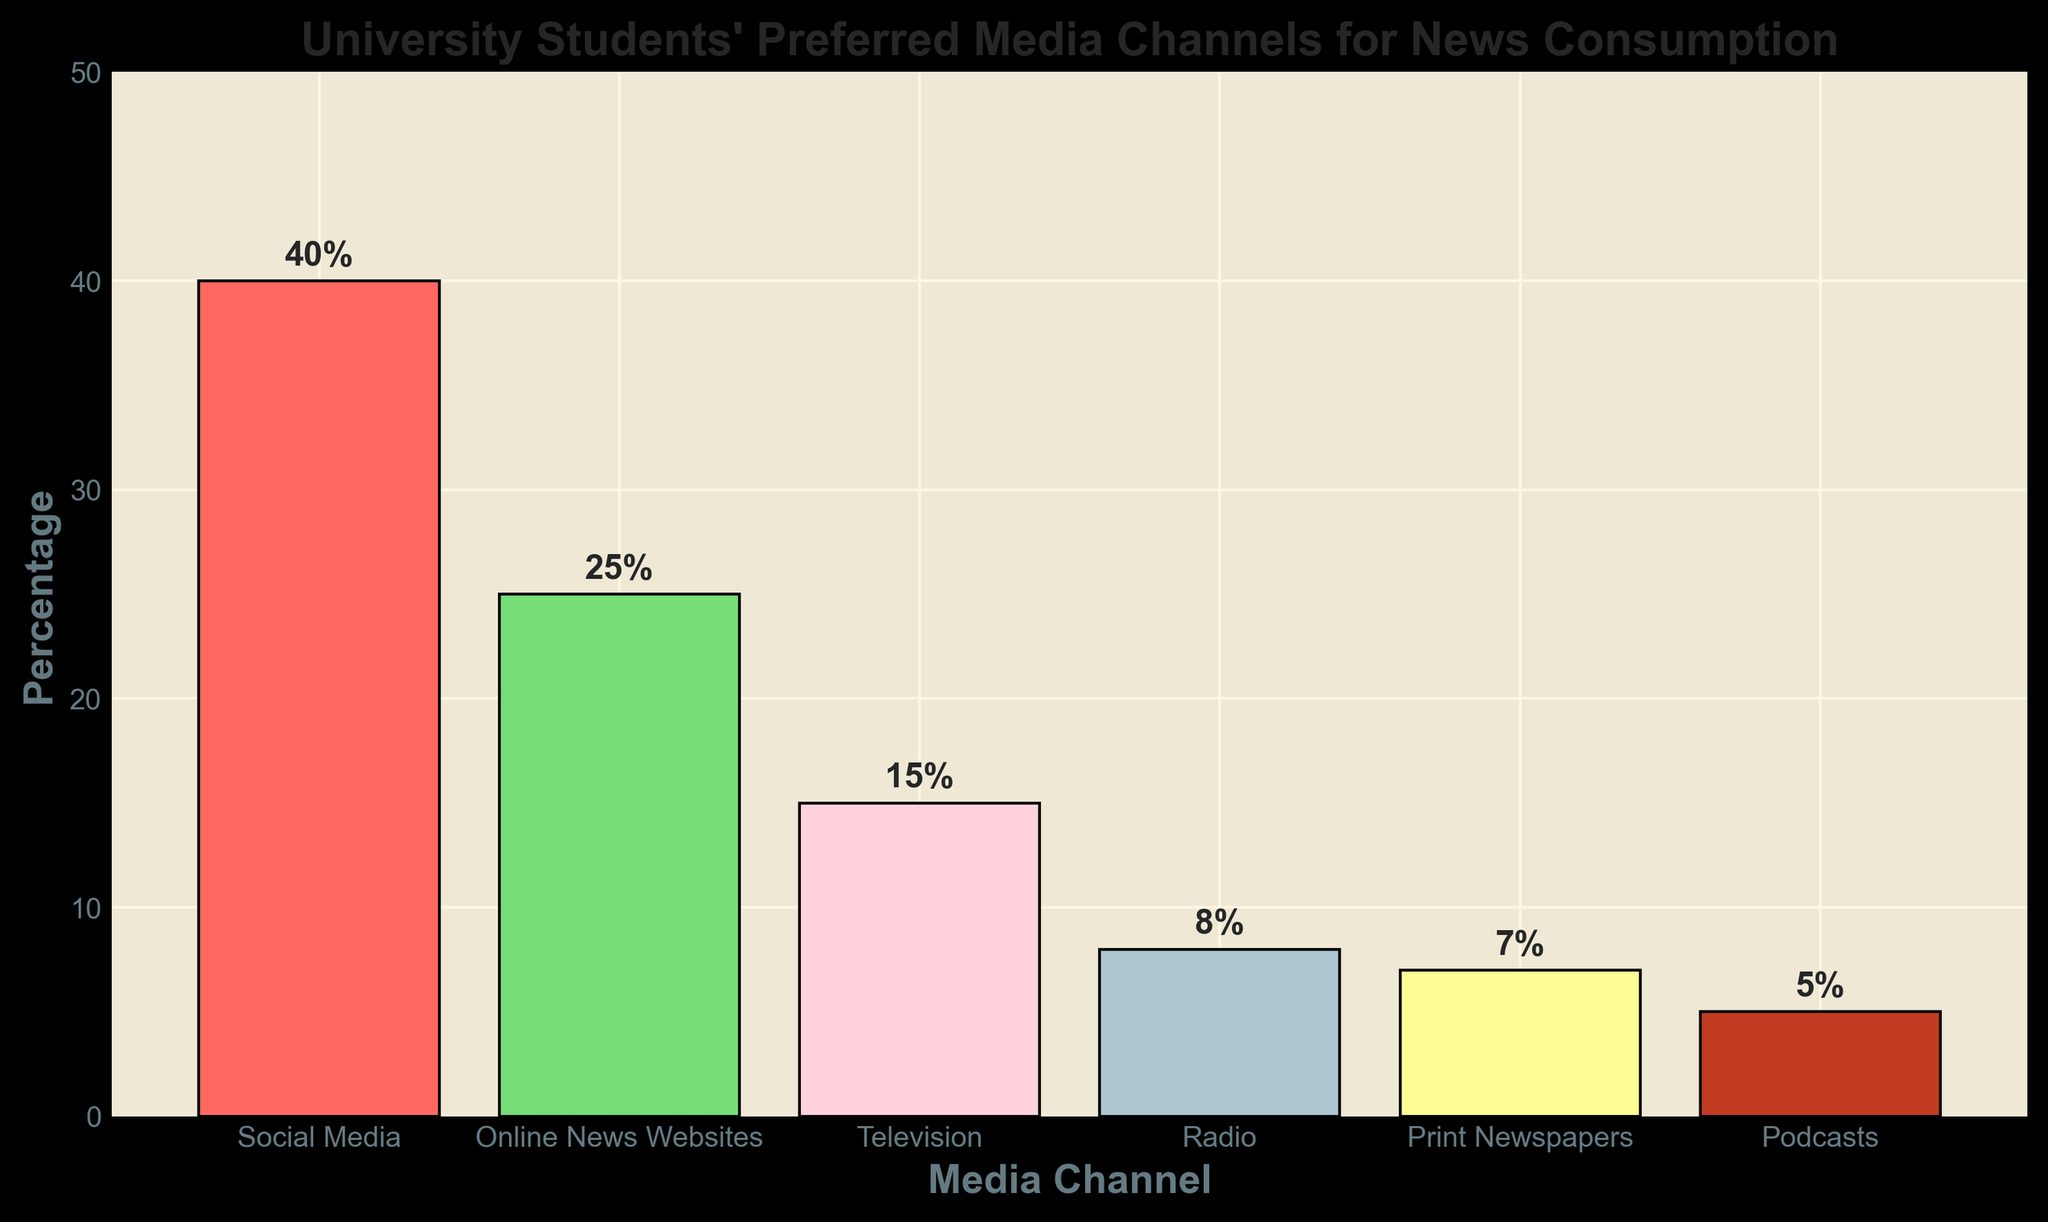Which media channel do university students prefer the most for news consumption? Look at the bar chart and identify which bar is the tallest. The tallest bar represents Social Media.
Answer: Social Media Which media channel is least preferred by university students for news consumption? Identify the shortest bar in the bar chart, which represents Podcasts.
Answer: Podcasts How much more percentage do university students prefer Social Media over Online News Websites? Determine the percentage for Social Media (40%) and Online News Websites (25%). Then, subtract Online News Websites' percentage from Social Media's percentage (40% - 25% = 15%).
Answer: 15% What is the combined percentage of students who prefer Television and Radio for news consumption? Find the percentage values for Television (15%) and Radio (8%). Add these percentages together (15% + 8% = 23%).
Answer: 23% Rank the media channels from most to least preferred. List the media channels in decreasing order based on their percentage values: Social Media (40%), Online News Websites (25%), Television (15%), Radio (8%), Print Newspapers (7%), Podcasts (5%).
Answer: Social Media > Online News Websites > Television > Radio > Print Newspapers > Podcasts How do Print Newspapers and Podcasts compare in terms of student preference? Compare the height of the bars for Print Newspapers and Podcasts, which are 7% and 5% respectively. Print Newspapers are preferred over Podcasts.
Answer: Print Newspapers are more preferred than Podcasts What is the average percentage of the top three preferred media channels? Identify the top three preferred media channels: Social Media (40%), Online News Websites (25%), and Television (15%). Calculate the average: (40% + 25% + 15%) / 3 = 80% / 3 ≈ 26.67%.
Answer: 26.67% Is the total percentage of students who prefer Radio and Print Newspapers greater than those who prefer Online News Websites? Add the percentages of students who prefer Radio (8%) and Print Newspapers (7%) and compare the sum (8% + 7% = 15%) to the percentage of Online News Websites (25%). 15% < 25%, so no.
Answer: No What is the percentage gap between the most preferred and least preferred media channels? Identify the percentages for the most preferred channel (Social Media, 40%) and least preferred channel (Podcasts, 5%). Calculate the difference: 40% - 5% = 35%.
Answer: 35% Which media channel, among Online News Websites and Print Newspapers, has a higher student preference, and by how much? Compare the percentage values for Online News Websites (25%) and Print Newspapers (7%). The difference is 25% - 7% = 18%.
Answer: Online News Websites by 18% 